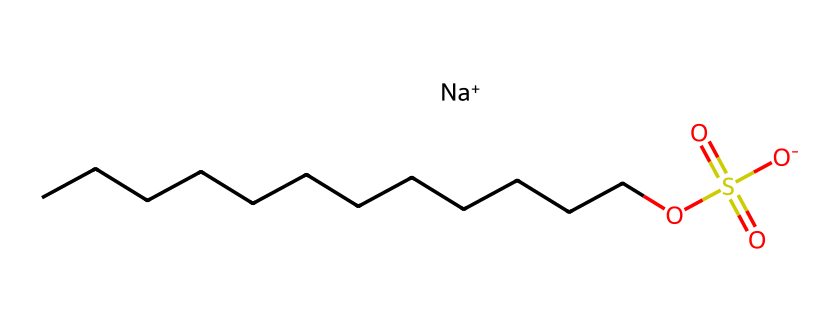What is the total number of carbon atoms in sodium dodecyl sulfate? The chemical structure shows a straight chain of carbon atoms indicated by the "CCCCCCCCCCCC", which clearly has 12 carbon atoms in total.
Answer: 12 How many sulfate groups are present in sodium dodecyl sulfate? In the SMILES representation, the "S(=O)(=O)O" part indicates that there is one sulfur atom bonded to four oxygen atoms, characteristic of one sulfate group.
Answer: 1 What is the charge of the sodium ion in this chemical? The chemical includes "[Na+]", indicating that it carries a positive charge.
Answer: positive How does the long hydrocarbon chain affect the solubility of sodium dodecyl sulfate? The long hydrocarbon chain increases the hydrophobic nature of the molecule, enhancing its ability to interact with oils and dirt while the sulfate head is hydrophilic, allowing it to dissolve in water, thus improving its surfactant properties.
Answer: enhances solubility What type of functional group is present in sodium dodecyl sulfate? The presence of the "S(=O)(=O)O" indicates that the functional group in this compound is a sulfate.
Answer: sulfate In what type of cleaning products is sodium dodecyl sulfate commonly found? Sodium dodecyl sulfate is commonly utilized in personal care products such as shampoos and body washes due to its effective surfactant properties that help in creating lather and removing dirt.
Answer: personal care products 